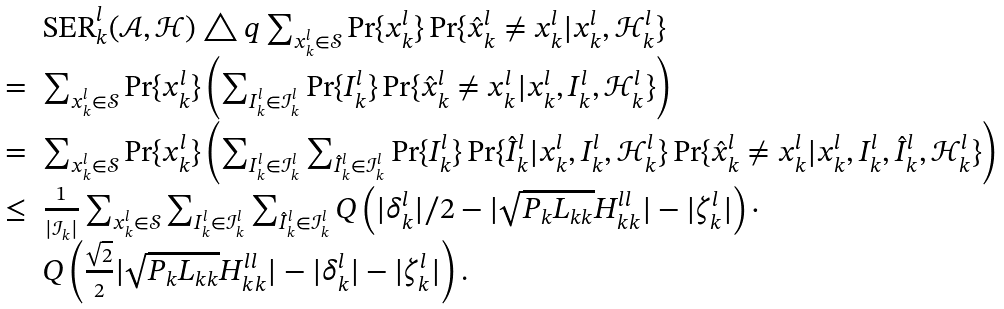<formula> <loc_0><loc_0><loc_500><loc_500>\begin{array} { l l l } & \text {SER} _ { k } ^ { l } ( \mathcal { A } , \mathcal { H } ) \triangle q \sum _ { x _ { k } ^ { l } \in \mathcal { S } } \Pr \{ x _ { k } ^ { l } \} \Pr \{ \hat { x } _ { k } ^ { l } \neq x _ { k } ^ { l } | x _ { k } ^ { l } , \mathcal { H } _ { k } ^ { l } \} \\ = & \sum _ { x _ { k } ^ { l } \in \mathcal { S } } \Pr \{ x _ { k } ^ { l } \} \left ( \sum _ { I _ { k } ^ { l } \in \mathcal { I } _ { k } ^ { l } } \Pr \{ I _ { k } ^ { l } \} \Pr \{ \hat { x } _ { k } ^ { l } \neq x _ { k } ^ { l } | x _ { k } ^ { l } , I _ { k } ^ { l } , \mathcal { H } _ { k } ^ { l } \} \right ) \\ = & \sum _ { x _ { k } ^ { l } \in \mathcal { S } } \Pr \{ x _ { k } ^ { l } \} \left ( \sum _ { I _ { k } ^ { l } \in \mathcal { I } _ { k } ^ { l } } \sum _ { \hat { I } _ { k } ^ { l } \in \mathcal { I } _ { k } ^ { l } } \Pr \{ I _ { k } ^ { l } \} \Pr \{ \hat { I } _ { k } ^ { l } | x _ { k } ^ { l } , I _ { k } ^ { l } , \mathcal { H } _ { k } ^ { l } \} \Pr \{ \hat { x } _ { k } ^ { l } \neq x _ { k } ^ { l } | x _ { k } ^ { l } , I _ { k } ^ { l } , \hat { I } _ { k } ^ { l } , \mathcal { H } _ { k } ^ { l } \} \right ) \\ \leq & \frac { 1 } { | \mathcal { I } _ { k } | } \sum _ { x _ { k } ^ { l } \in \mathcal { S } } \sum _ { I _ { k } ^ { l } \in \mathcal { I } _ { k } ^ { l } } \sum _ { \hat { I } _ { k } ^ { l } \in \mathcal { I } _ { k } ^ { l } } Q \left ( | \delta _ { k } ^ { l } | / 2 - | \sqrt { P _ { k } L _ { k k } } H _ { k k } ^ { l l } | - | \zeta _ { k } ^ { l } | \right ) \cdot \\ & Q \left ( \frac { \sqrt { 2 } } { 2 } | \sqrt { P _ { k } L _ { k k } } H _ { k k } ^ { l l } | - | \delta _ { k } ^ { l } | - | \zeta _ { k } ^ { l } | \right ) . \end{array}</formula> 